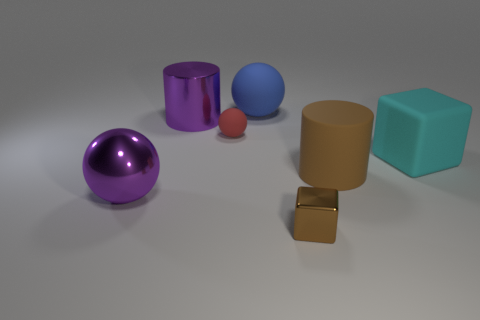What is the big cube in front of the red rubber thing on the right side of the large cylinder that is on the left side of the brown cube made of?
Provide a succinct answer. Rubber. What number of other things are there of the same size as the purple metallic ball?
Your response must be concise. 4. There is a thing that is the same color as the metal ball; what size is it?
Keep it short and to the point. Large. Are there more large blue balls that are to the right of the small shiny thing than shiny cubes?
Your answer should be very brief. No. Are there any rubber objects that have the same color as the metal ball?
Your response must be concise. No. The other object that is the same size as the red rubber thing is what color?
Your response must be concise. Brown. There is a cylinder that is in front of the tiny ball; what number of large things are in front of it?
Make the answer very short. 1. What number of things are big objects that are in front of the cyan rubber object or big rubber cylinders?
Keep it short and to the point. 2. What number of big purple cylinders have the same material as the small red sphere?
Give a very brief answer. 0. What shape is the metallic object that is the same color as the big matte cylinder?
Ensure brevity in your answer.  Cube. 